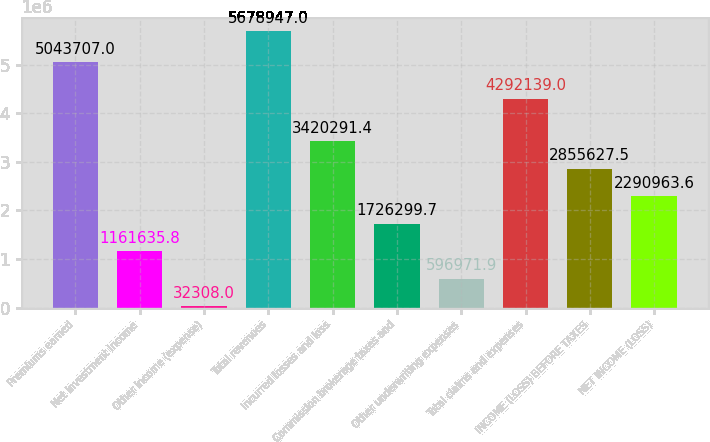Convert chart to OTSL. <chart><loc_0><loc_0><loc_500><loc_500><bar_chart><fcel>Premiums earned<fcel>Net investment income<fcel>Other income (expense)<fcel>Total revenues<fcel>Incurred losses and loss<fcel>Commission brokerage taxes and<fcel>Other underwriting expenses<fcel>Total claims and expenses<fcel>INCOME (LOSS) BEFORE TAXES<fcel>NET INCOME (LOSS)<nl><fcel>5.04371e+06<fcel>1.16164e+06<fcel>32308<fcel>5.67895e+06<fcel>3.42029e+06<fcel>1.7263e+06<fcel>596972<fcel>4.29214e+06<fcel>2.85563e+06<fcel>2.29096e+06<nl></chart> 